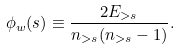<formula> <loc_0><loc_0><loc_500><loc_500>\phi _ { w } ( s ) \equiv \frac { 2 E _ { > s } } { n _ { > s } ( n _ { > s } - 1 ) } .</formula> 